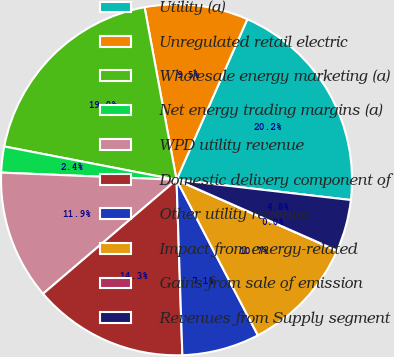Convert chart to OTSL. <chart><loc_0><loc_0><loc_500><loc_500><pie_chart><fcel>Utility (a)<fcel>Unregulated retail electric<fcel>Wholesale energy marketing (a)<fcel>Net energy trading margins (a)<fcel>WPD utility revenue<fcel>Domestic delivery component of<fcel>Other utility revenue<fcel>Impact from energy-related<fcel>Gains from sale of emission<fcel>Revenues from Supply segment<nl><fcel>20.23%<fcel>9.52%<fcel>19.04%<fcel>2.39%<fcel>11.9%<fcel>14.28%<fcel>7.14%<fcel>10.71%<fcel>0.01%<fcel>4.77%<nl></chart> 